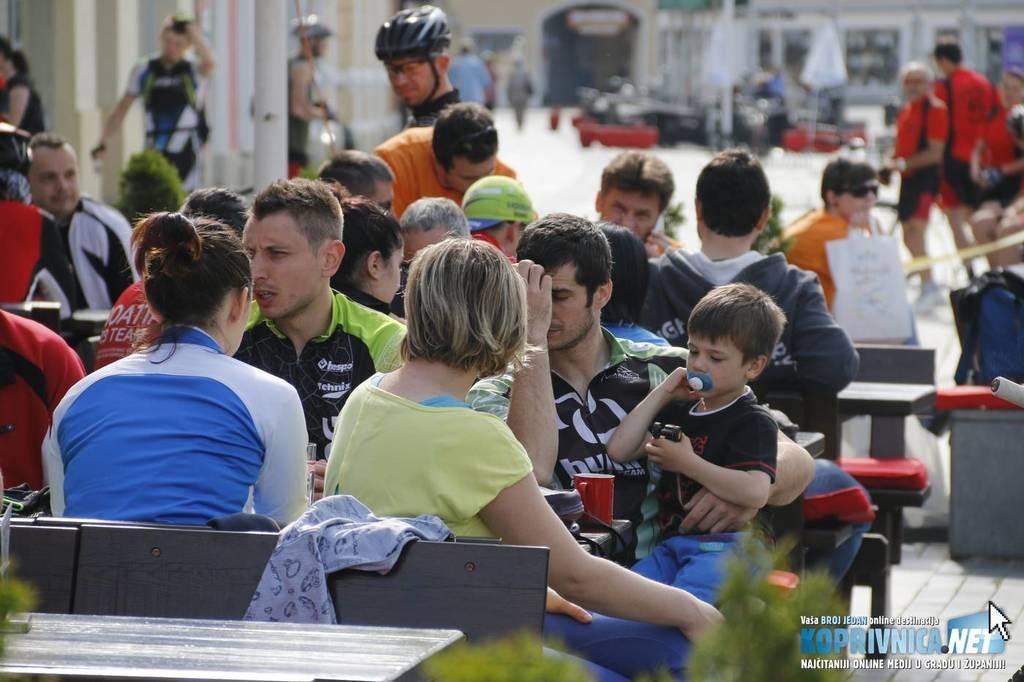In one or two sentences, can you explain what this image depicts? In this image there are some persons sitting on the benches as we can see at bottom of this image and there are some persons standing in the background and there is a building at top of this image and there is one watermark place at bottom right corner of this image. 